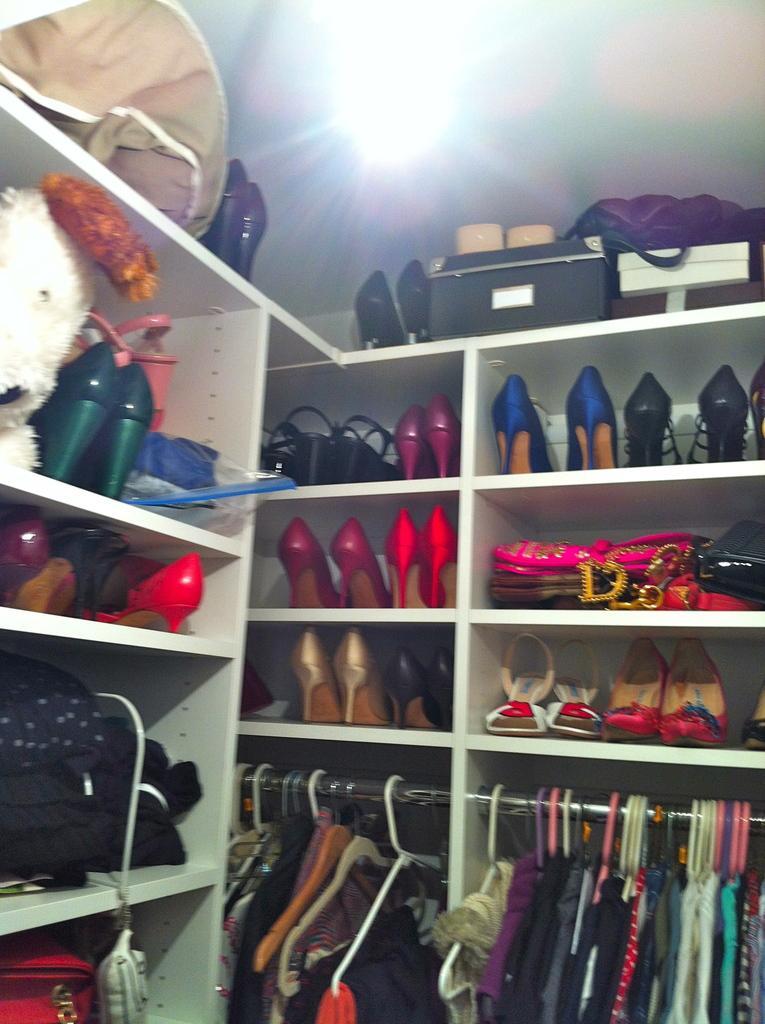How would you summarize this image in a sentence or two? In this image we can see slippers, dresses, handbags and some objects arranged in shelves. 